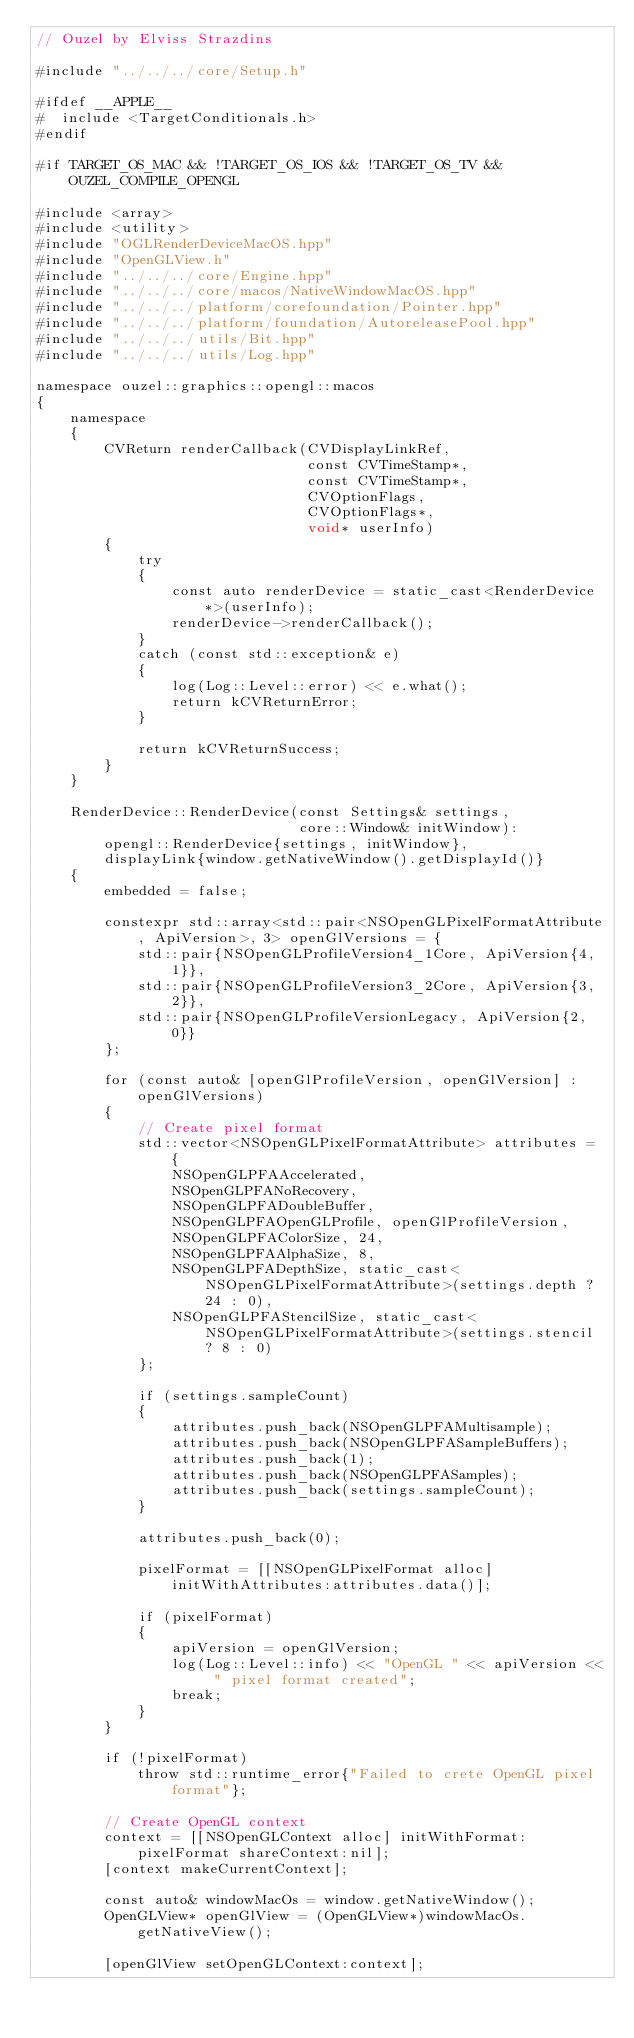<code> <loc_0><loc_0><loc_500><loc_500><_ObjectiveC_>// Ouzel by Elviss Strazdins

#include "../../../core/Setup.h"

#ifdef __APPLE__
#  include <TargetConditionals.h>
#endif

#if TARGET_OS_MAC && !TARGET_OS_IOS && !TARGET_OS_TV && OUZEL_COMPILE_OPENGL

#include <array>
#include <utility>
#include "OGLRenderDeviceMacOS.hpp"
#include "OpenGLView.h"
#include "../../../core/Engine.hpp"
#include "../../../core/macos/NativeWindowMacOS.hpp"
#include "../../../platform/corefoundation/Pointer.hpp"
#include "../../../platform/foundation/AutoreleasePool.hpp"
#include "../../../utils/Bit.hpp"
#include "../../../utils/Log.hpp"

namespace ouzel::graphics::opengl::macos
{
    namespace
    {
        CVReturn renderCallback(CVDisplayLinkRef,
                                const CVTimeStamp*,
                                const CVTimeStamp*,
                                CVOptionFlags,
                                CVOptionFlags*,
                                void* userInfo)
        {
            try
            {
                const auto renderDevice = static_cast<RenderDevice*>(userInfo);
                renderDevice->renderCallback();
            }
            catch (const std::exception& e)
            {
                log(Log::Level::error) << e.what();
                return kCVReturnError;
            }

            return kCVReturnSuccess;
        }
    }

    RenderDevice::RenderDevice(const Settings& settings,
                               core::Window& initWindow):
        opengl::RenderDevice{settings, initWindow},
        displayLink{window.getNativeWindow().getDisplayId()}
    {
        embedded = false;

        constexpr std::array<std::pair<NSOpenGLPixelFormatAttribute, ApiVersion>, 3> openGlVersions = {
            std::pair{NSOpenGLProfileVersion4_1Core, ApiVersion{4, 1}},
            std::pair{NSOpenGLProfileVersion3_2Core, ApiVersion{3, 2}},
            std::pair{NSOpenGLProfileVersionLegacy, ApiVersion{2, 0}}
        };

        for (const auto& [openGlProfileVersion, openGlVersion] : openGlVersions)
        {
            // Create pixel format
            std::vector<NSOpenGLPixelFormatAttribute> attributes = {
                NSOpenGLPFAAccelerated,
                NSOpenGLPFANoRecovery,
                NSOpenGLPFADoubleBuffer,
                NSOpenGLPFAOpenGLProfile, openGlProfileVersion,
                NSOpenGLPFAColorSize, 24,
                NSOpenGLPFAAlphaSize, 8,
                NSOpenGLPFADepthSize, static_cast<NSOpenGLPixelFormatAttribute>(settings.depth ? 24 : 0),
                NSOpenGLPFAStencilSize, static_cast<NSOpenGLPixelFormatAttribute>(settings.stencil ? 8 : 0)
            };

            if (settings.sampleCount)
            {
                attributes.push_back(NSOpenGLPFAMultisample);
                attributes.push_back(NSOpenGLPFASampleBuffers);
                attributes.push_back(1);
                attributes.push_back(NSOpenGLPFASamples);
                attributes.push_back(settings.sampleCount);
            }

            attributes.push_back(0);

            pixelFormat = [[NSOpenGLPixelFormat alloc] initWithAttributes:attributes.data()];

            if (pixelFormat)
            {
                apiVersion = openGlVersion;
                log(Log::Level::info) << "OpenGL " << apiVersion << " pixel format created";
                break;
            }
        }

        if (!pixelFormat)
            throw std::runtime_error{"Failed to crete OpenGL pixel format"};

        // Create OpenGL context
        context = [[NSOpenGLContext alloc] initWithFormat:pixelFormat shareContext:nil];
        [context makeCurrentContext];

        const auto& windowMacOs = window.getNativeWindow();
        OpenGLView* openGlView = (OpenGLView*)windowMacOs.getNativeView();

        [openGlView setOpenGLContext:context];</code> 